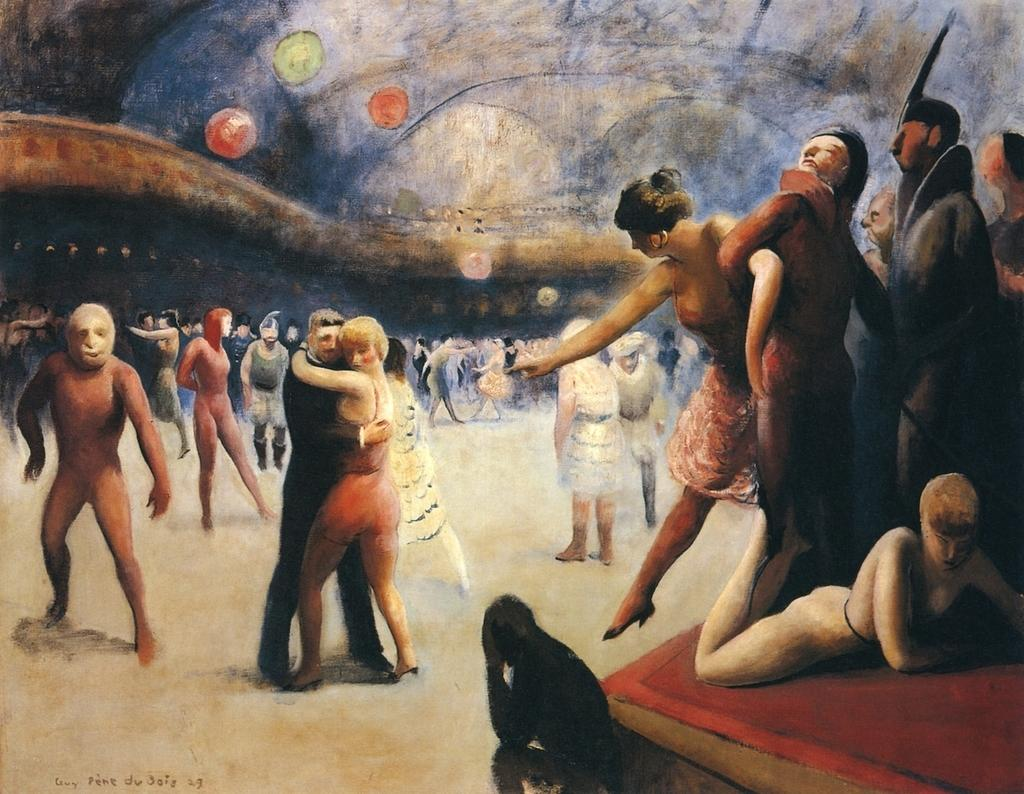How many persons are in the image? There are persons in the image, but the exact number is not specified. What are some of the actions being performed by the persons in the image? Some persons are standing, some are laying, and some are hugging. Are there any shapes or symbols present in the image? Yes, there are three circles at the top of the image. What type of quiver can be seen in the image? There is no quiver present in the image. How does the drain affect the persons in the image? There is no drain present in the image, so it cannot affect the persons. 